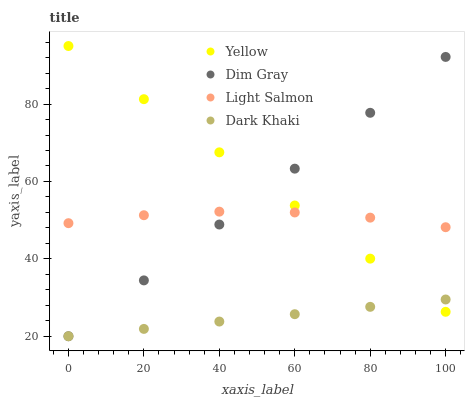Does Dark Khaki have the minimum area under the curve?
Answer yes or no. Yes. Does Yellow have the maximum area under the curve?
Answer yes or no. Yes. Does Light Salmon have the minimum area under the curve?
Answer yes or no. No. Does Light Salmon have the maximum area under the curve?
Answer yes or no. No. Is Dark Khaki the smoothest?
Answer yes or no. Yes. Is Light Salmon the roughest?
Answer yes or no. Yes. Is Dim Gray the smoothest?
Answer yes or no. No. Is Dim Gray the roughest?
Answer yes or no. No. Does Dark Khaki have the lowest value?
Answer yes or no. Yes. Does Light Salmon have the lowest value?
Answer yes or no. No. Does Yellow have the highest value?
Answer yes or no. Yes. Does Light Salmon have the highest value?
Answer yes or no. No. Is Dark Khaki less than Light Salmon?
Answer yes or no. Yes. Is Light Salmon greater than Dark Khaki?
Answer yes or no. Yes. Does Dim Gray intersect Yellow?
Answer yes or no. Yes. Is Dim Gray less than Yellow?
Answer yes or no. No. Is Dim Gray greater than Yellow?
Answer yes or no. No. Does Dark Khaki intersect Light Salmon?
Answer yes or no. No. 